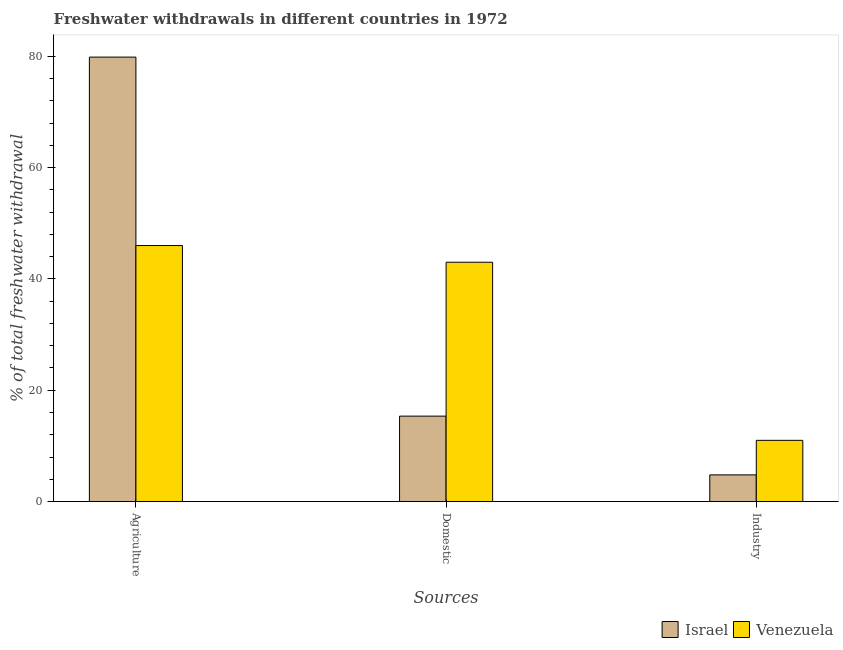How many different coloured bars are there?
Your answer should be very brief. 2. Are the number of bars per tick equal to the number of legend labels?
Provide a succinct answer. Yes. How many bars are there on the 3rd tick from the right?
Your response must be concise. 2. What is the label of the 1st group of bars from the left?
Give a very brief answer. Agriculture. What is the percentage of freshwater withdrawal for agriculture in Venezuela?
Make the answer very short. 46. Across all countries, what is the minimum percentage of freshwater withdrawal for agriculture?
Give a very brief answer. 46. In which country was the percentage of freshwater withdrawal for industry maximum?
Offer a terse response. Venezuela. In which country was the percentage of freshwater withdrawal for domestic purposes minimum?
Your response must be concise. Israel. What is the total percentage of freshwater withdrawal for industry in the graph?
Give a very brief answer. 15.79. What is the difference between the percentage of freshwater withdrawal for agriculture in Israel and that in Venezuela?
Your answer should be compact. 33.86. What is the difference between the percentage of freshwater withdrawal for industry in Venezuela and the percentage of freshwater withdrawal for agriculture in Israel?
Your answer should be compact. -68.86. What is the average percentage of freshwater withdrawal for industry per country?
Offer a terse response. 7.9. What is the difference between the percentage of freshwater withdrawal for industry and percentage of freshwater withdrawal for domestic purposes in Israel?
Ensure brevity in your answer.  -10.55. What is the ratio of the percentage of freshwater withdrawal for agriculture in Venezuela to that in Israel?
Offer a terse response. 0.58. Is the percentage of freshwater withdrawal for domestic purposes in Israel less than that in Venezuela?
Offer a terse response. Yes. What is the difference between the highest and the second highest percentage of freshwater withdrawal for domestic purposes?
Your answer should be very brief. 27.65. What is the difference between the highest and the lowest percentage of freshwater withdrawal for domestic purposes?
Your answer should be compact. 27.65. What does the 1st bar from the right in Domestic represents?
Your answer should be compact. Venezuela. How many bars are there?
Your answer should be very brief. 6. Are the values on the major ticks of Y-axis written in scientific E-notation?
Provide a succinct answer. No. How are the legend labels stacked?
Give a very brief answer. Horizontal. What is the title of the graph?
Offer a very short reply. Freshwater withdrawals in different countries in 1972. What is the label or title of the X-axis?
Offer a terse response. Sources. What is the label or title of the Y-axis?
Your answer should be very brief. % of total freshwater withdrawal. What is the % of total freshwater withdrawal in Israel in Agriculture?
Keep it short and to the point. 79.86. What is the % of total freshwater withdrawal of Israel in Domestic?
Keep it short and to the point. 15.35. What is the % of total freshwater withdrawal in Venezuela in Domestic?
Your answer should be very brief. 43. What is the % of total freshwater withdrawal of Israel in Industry?
Offer a very short reply. 4.79. What is the % of total freshwater withdrawal in Venezuela in Industry?
Keep it short and to the point. 11. Across all Sources, what is the maximum % of total freshwater withdrawal in Israel?
Offer a terse response. 79.86. Across all Sources, what is the maximum % of total freshwater withdrawal of Venezuela?
Make the answer very short. 46. Across all Sources, what is the minimum % of total freshwater withdrawal of Israel?
Make the answer very short. 4.79. Across all Sources, what is the minimum % of total freshwater withdrawal in Venezuela?
Your answer should be compact. 11. What is the total % of total freshwater withdrawal in Israel in the graph?
Your answer should be very brief. 100. What is the difference between the % of total freshwater withdrawal in Israel in Agriculture and that in Domestic?
Offer a terse response. 64.51. What is the difference between the % of total freshwater withdrawal of Israel in Agriculture and that in Industry?
Your answer should be very brief. 75.06. What is the difference between the % of total freshwater withdrawal of Venezuela in Agriculture and that in Industry?
Your answer should be very brief. 35. What is the difference between the % of total freshwater withdrawal of Israel in Domestic and that in Industry?
Provide a short and direct response. 10.55. What is the difference between the % of total freshwater withdrawal in Venezuela in Domestic and that in Industry?
Offer a terse response. 32. What is the difference between the % of total freshwater withdrawal in Israel in Agriculture and the % of total freshwater withdrawal in Venezuela in Domestic?
Provide a short and direct response. 36.86. What is the difference between the % of total freshwater withdrawal in Israel in Agriculture and the % of total freshwater withdrawal in Venezuela in Industry?
Your answer should be compact. 68.86. What is the difference between the % of total freshwater withdrawal in Israel in Domestic and the % of total freshwater withdrawal in Venezuela in Industry?
Make the answer very short. 4.35. What is the average % of total freshwater withdrawal in Israel per Sources?
Your response must be concise. 33.34. What is the average % of total freshwater withdrawal in Venezuela per Sources?
Provide a succinct answer. 33.33. What is the difference between the % of total freshwater withdrawal of Israel and % of total freshwater withdrawal of Venezuela in Agriculture?
Provide a short and direct response. 33.86. What is the difference between the % of total freshwater withdrawal of Israel and % of total freshwater withdrawal of Venezuela in Domestic?
Offer a very short reply. -27.65. What is the difference between the % of total freshwater withdrawal in Israel and % of total freshwater withdrawal in Venezuela in Industry?
Your answer should be very brief. -6.21. What is the ratio of the % of total freshwater withdrawal in Israel in Agriculture to that in Domestic?
Provide a succinct answer. 5.2. What is the ratio of the % of total freshwater withdrawal in Venezuela in Agriculture to that in Domestic?
Your response must be concise. 1.07. What is the ratio of the % of total freshwater withdrawal in Israel in Agriculture to that in Industry?
Offer a very short reply. 16.65. What is the ratio of the % of total freshwater withdrawal in Venezuela in Agriculture to that in Industry?
Your answer should be very brief. 4.18. What is the ratio of the % of total freshwater withdrawal of Israel in Domestic to that in Industry?
Ensure brevity in your answer.  3.2. What is the ratio of the % of total freshwater withdrawal of Venezuela in Domestic to that in Industry?
Your answer should be compact. 3.91. What is the difference between the highest and the second highest % of total freshwater withdrawal in Israel?
Ensure brevity in your answer.  64.51. What is the difference between the highest and the second highest % of total freshwater withdrawal of Venezuela?
Make the answer very short. 3. What is the difference between the highest and the lowest % of total freshwater withdrawal of Israel?
Provide a short and direct response. 75.06. What is the difference between the highest and the lowest % of total freshwater withdrawal in Venezuela?
Give a very brief answer. 35. 